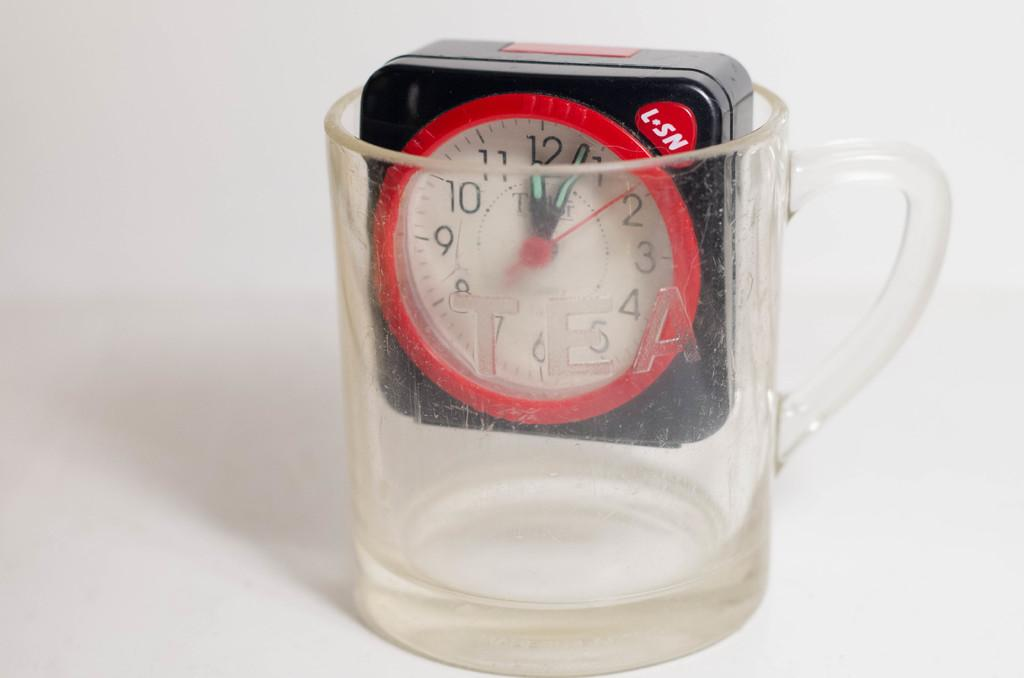<image>
Write a terse but informative summary of the picture. a clock with letters L-SN inside a clear mug 